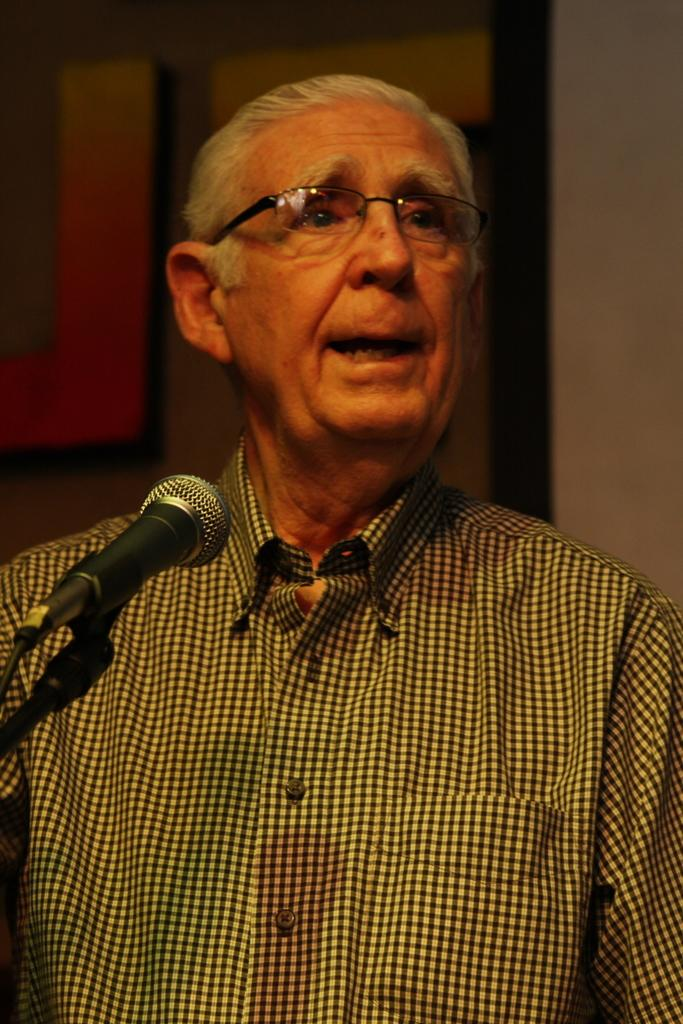What is the main subject of the image? There is a man standing in the image. What object is in front of the man? There is a microphone in front of the man. What is behind the man in the image? There is a wall behind the man. Can you describe the text on the wall in the image? There is text on the wall to the left. What type of birds can be seen flying in the image? There are no birds visible in the image. What kind of wave is depicted on the wall in the image? There is no wave depicted on the wall in the image; there is only text. 